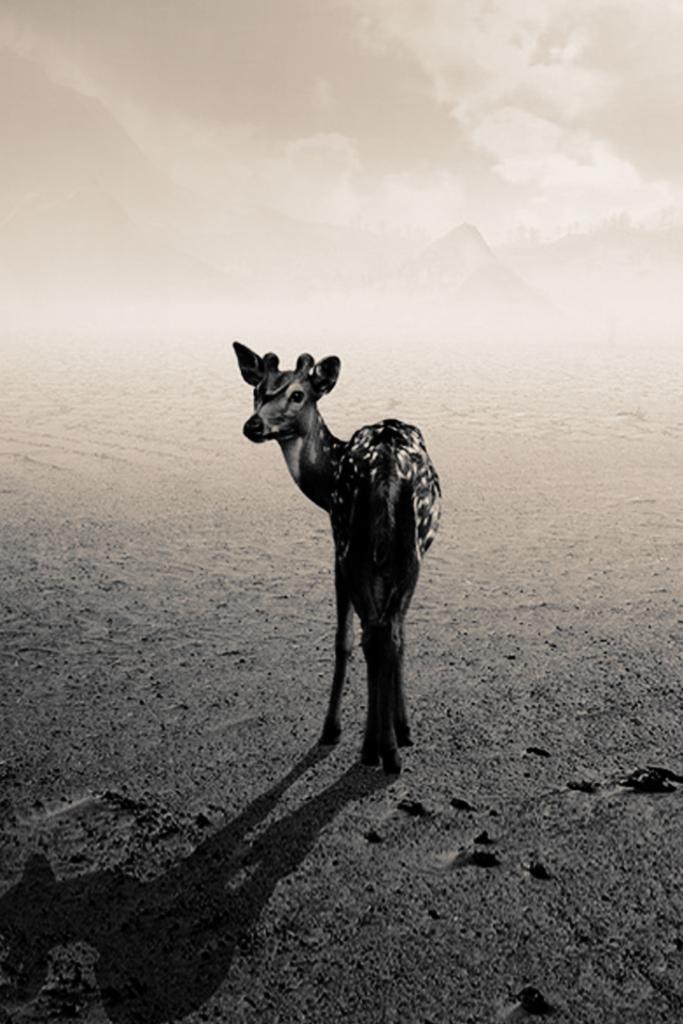Describe this image in one or two sentences. In this image, I can see an animal on the road. In the background, I can see mountains and the sky. This image taken, maybe during night. 